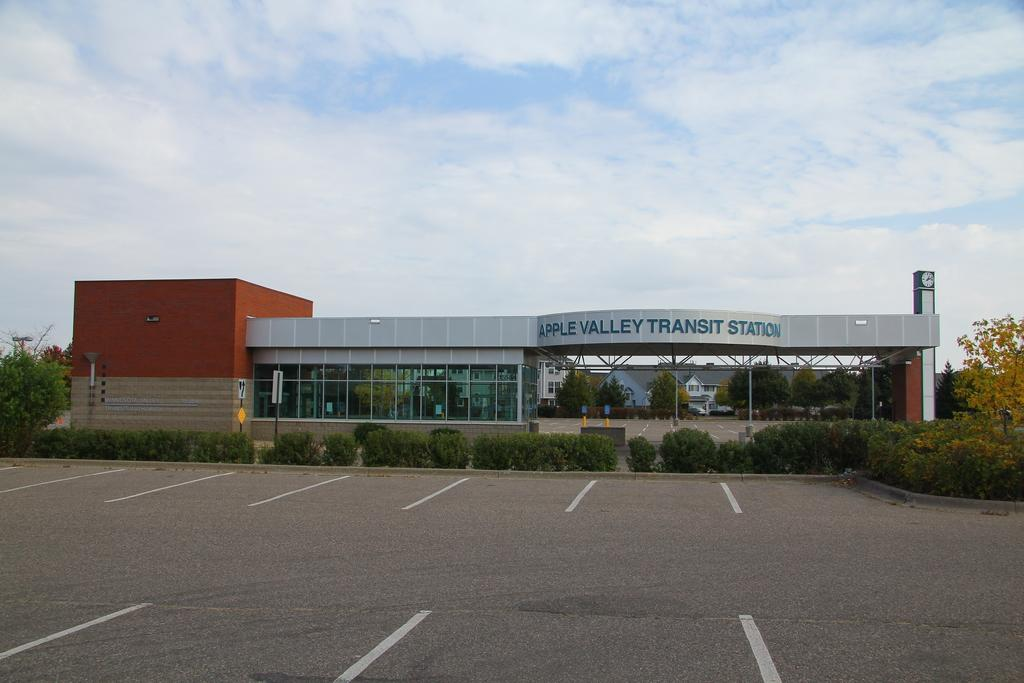Provide a one-sentence caption for the provided image. The parking lot of the Apple Valley Transit Station is empty. 